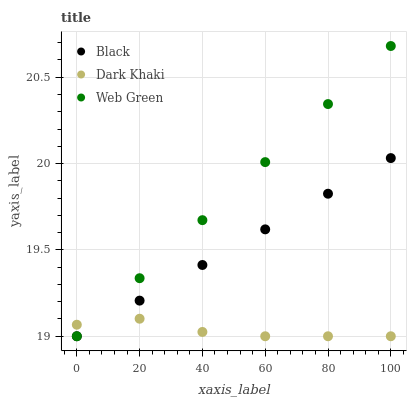Does Dark Khaki have the minimum area under the curve?
Answer yes or no. Yes. Does Web Green have the maximum area under the curve?
Answer yes or no. Yes. Does Black have the minimum area under the curve?
Answer yes or no. No. Does Black have the maximum area under the curve?
Answer yes or no. No. Is Black the smoothest?
Answer yes or no. Yes. Is Dark Khaki the roughest?
Answer yes or no. Yes. Is Web Green the roughest?
Answer yes or no. No. Does Dark Khaki have the lowest value?
Answer yes or no. Yes. Does Web Green have the highest value?
Answer yes or no. Yes. Does Black have the highest value?
Answer yes or no. No. Does Web Green intersect Black?
Answer yes or no. Yes. Is Web Green less than Black?
Answer yes or no. No. Is Web Green greater than Black?
Answer yes or no. No. 